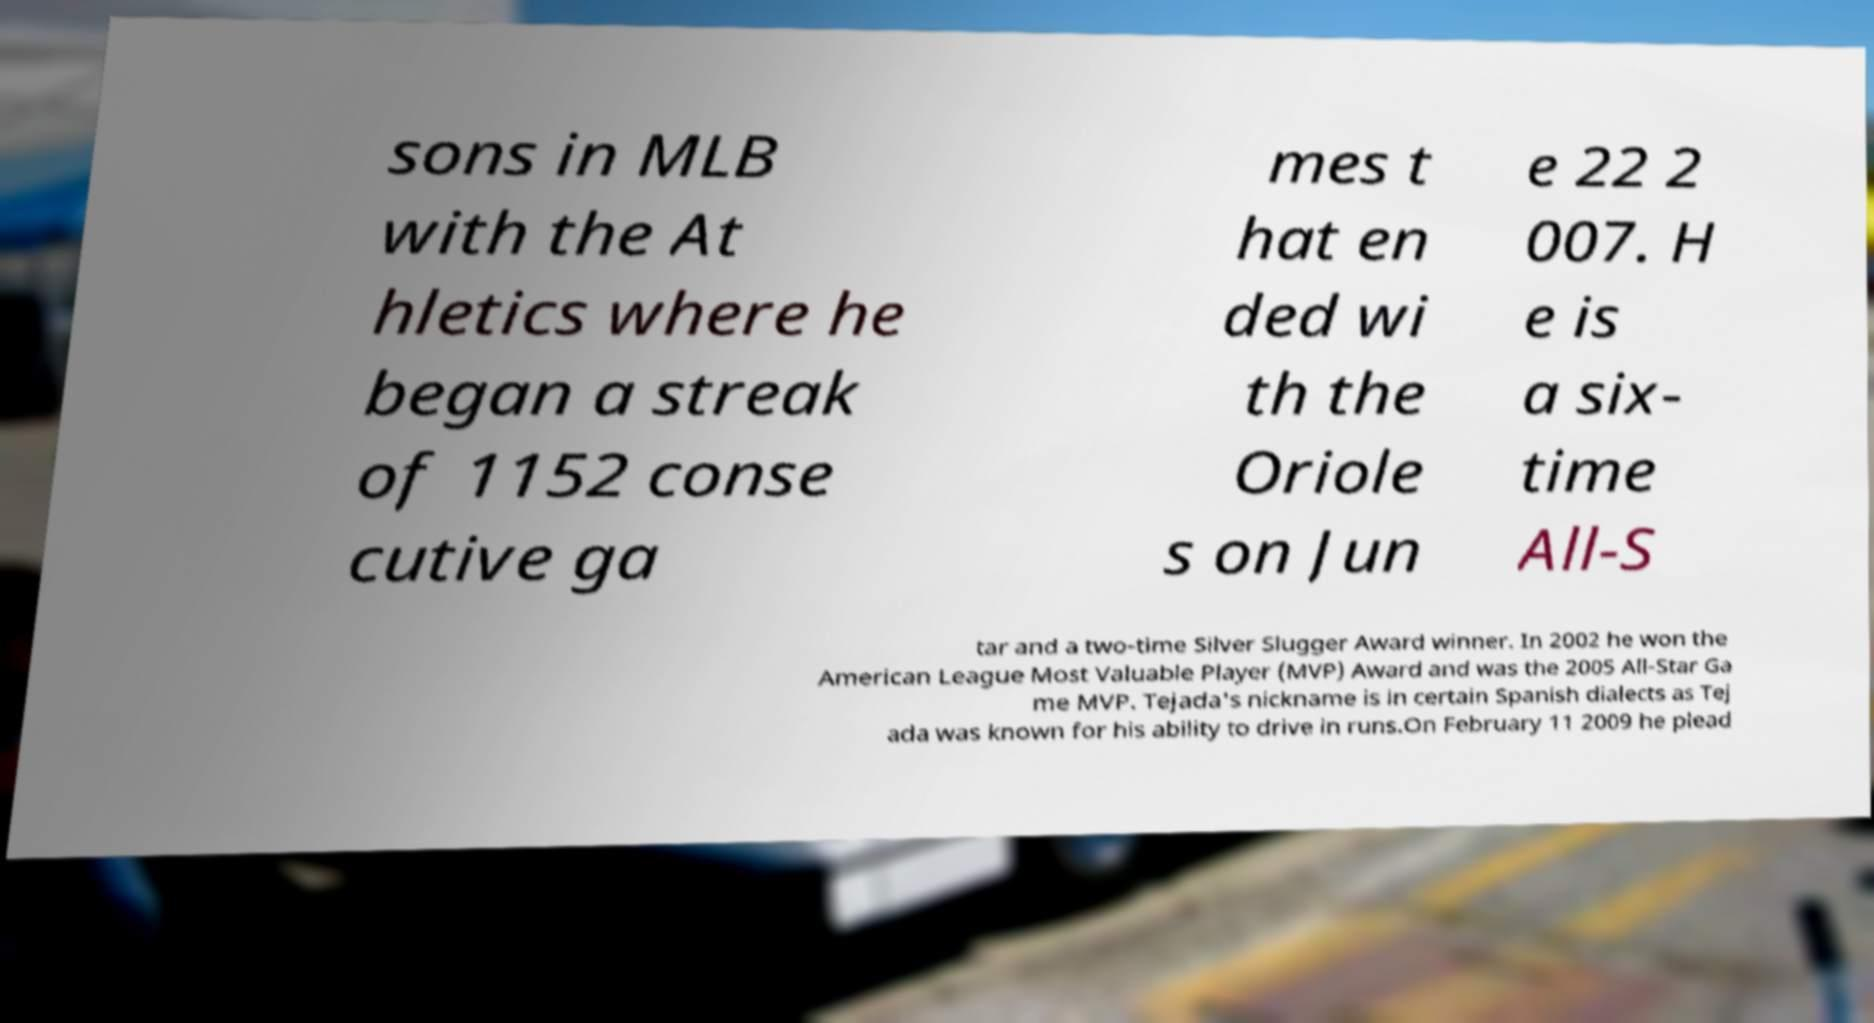For documentation purposes, I need the text within this image transcribed. Could you provide that? sons in MLB with the At hletics where he began a streak of 1152 conse cutive ga mes t hat en ded wi th the Oriole s on Jun e 22 2 007. H e is a six- time All-S tar and a two-time Silver Slugger Award winner. In 2002 he won the American League Most Valuable Player (MVP) Award and was the 2005 All-Star Ga me MVP. Tejada's nickname is in certain Spanish dialects as Tej ada was known for his ability to drive in runs.On February 11 2009 he plead 